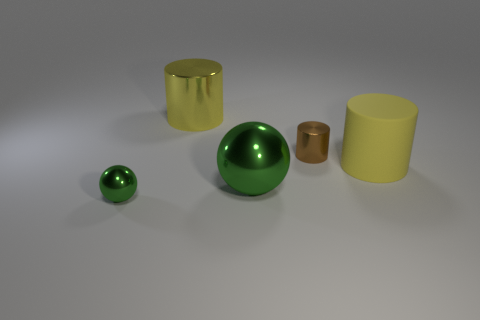What number of balls are large green metallic objects or big yellow objects?
Your answer should be very brief. 1. How many large green shiny things are on the left side of the large cylinder that is to the left of the yellow cylinder in front of the brown cylinder?
Your answer should be very brief. 0. Does the matte object have the same shape as the brown thing?
Provide a succinct answer. Yes. Is the material of the green object that is on the right side of the yellow metallic object the same as the large yellow object right of the large metal sphere?
Give a very brief answer. No. What number of things are either yellow cylinders behind the large yellow matte object or metallic cylinders left of the large green metallic object?
Offer a terse response. 1. What number of green spheres are there?
Keep it short and to the point. 2. Are there any green objects of the same size as the brown shiny cylinder?
Your response must be concise. Yes. Do the tiny ball and the yellow cylinder right of the big green thing have the same material?
Provide a short and direct response. No. What material is the green sphere left of the big green object?
Your response must be concise. Metal. The rubber cylinder has what size?
Make the answer very short. Large. 